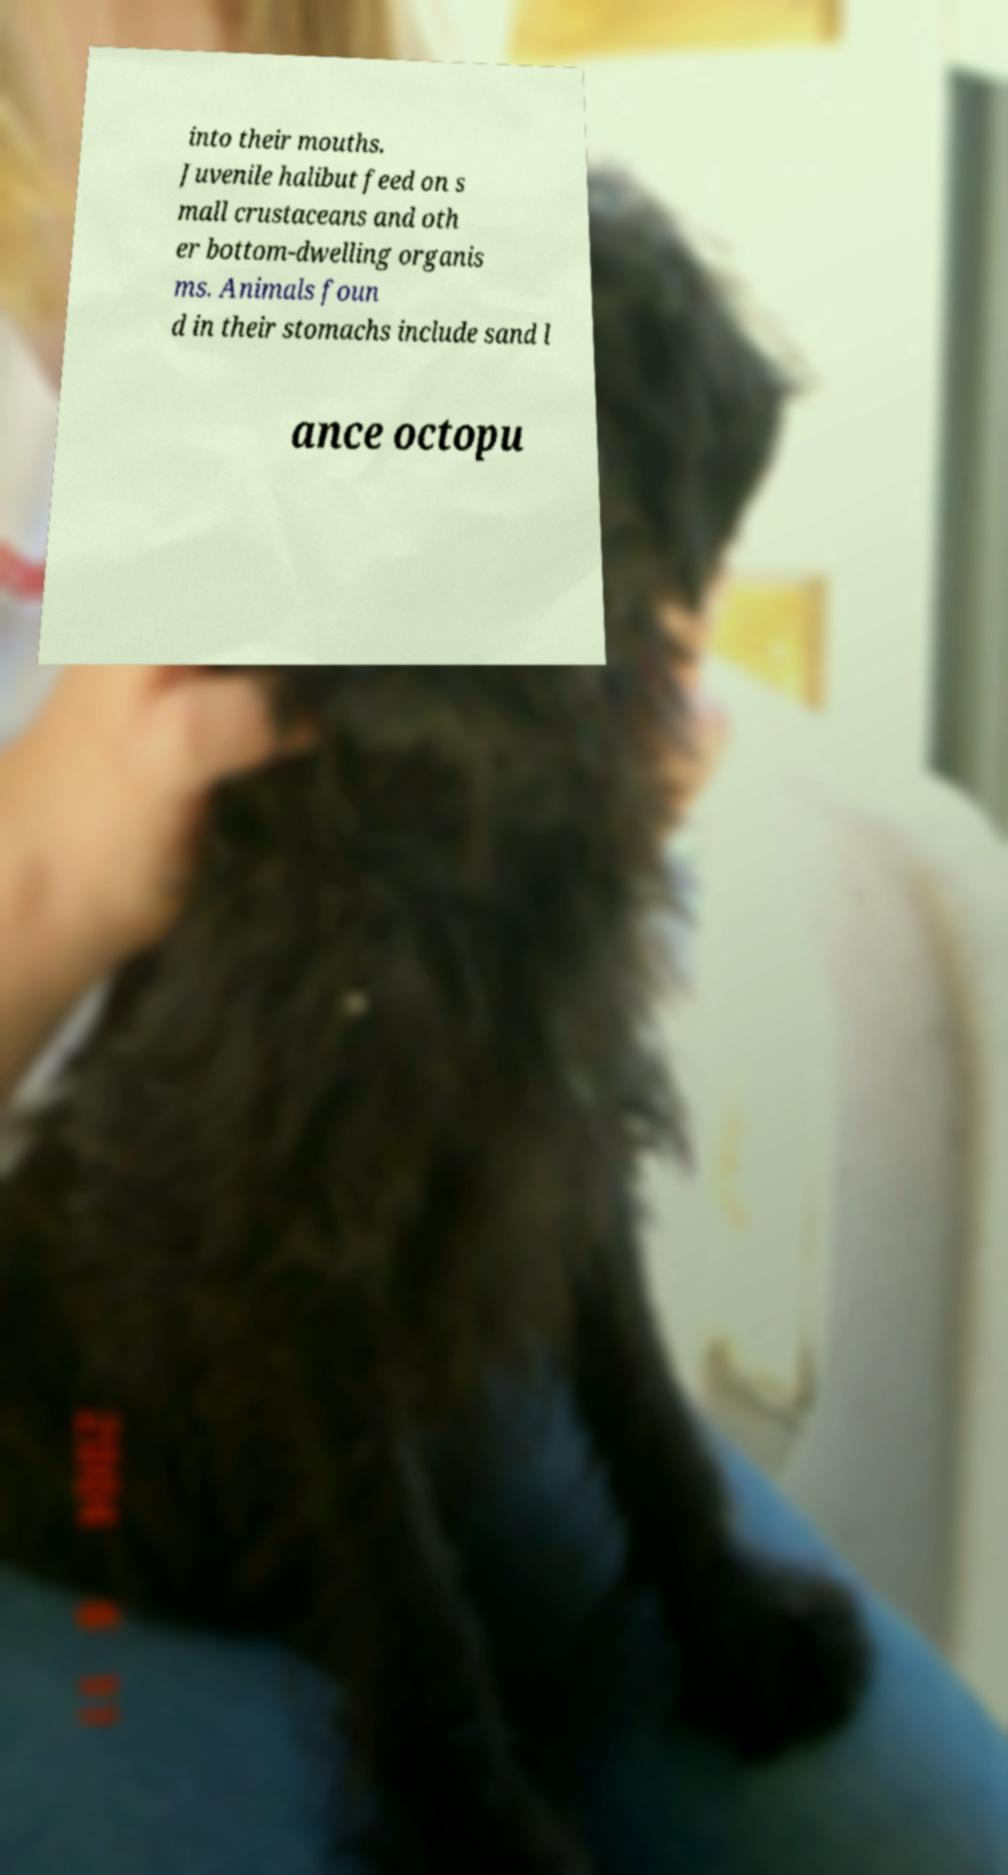I need the written content from this picture converted into text. Can you do that? into their mouths. Juvenile halibut feed on s mall crustaceans and oth er bottom-dwelling organis ms. Animals foun d in their stomachs include sand l ance octopu 